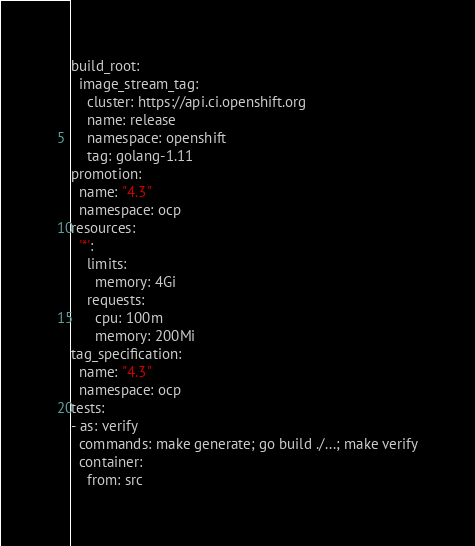<code> <loc_0><loc_0><loc_500><loc_500><_YAML_>build_root:
  image_stream_tag:
    cluster: https://api.ci.openshift.org
    name: release
    namespace: openshift
    tag: golang-1.11
promotion:
  name: "4.3"
  namespace: ocp
resources:
  '*':
    limits:
      memory: 4Gi
    requests:
      cpu: 100m
      memory: 200Mi
tag_specification:
  name: "4.3"
  namespace: ocp
tests:
- as: verify
  commands: make generate; go build ./...; make verify
  container:
    from: src
</code> 